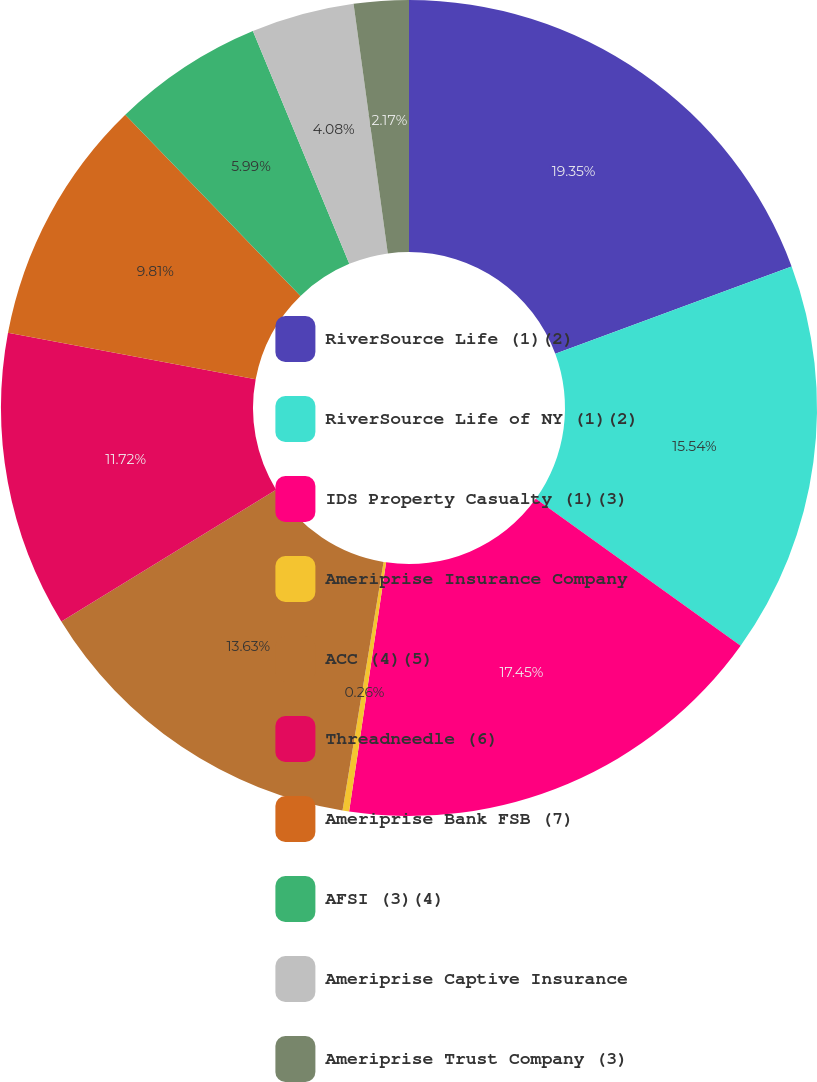Convert chart to OTSL. <chart><loc_0><loc_0><loc_500><loc_500><pie_chart><fcel>RiverSource Life (1)(2)<fcel>RiverSource Life of NY (1)(2)<fcel>IDS Property Casualty (1)(3)<fcel>Ameriprise Insurance Company<fcel>ACC (4)(5)<fcel>Threadneedle (6)<fcel>Ameriprise Bank FSB (7)<fcel>AFSI (3)(4)<fcel>Ameriprise Captive Insurance<fcel>Ameriprise Trust Company (3)<nl><fcel>19.36%<fcel>15.54%<fcel>17.45%<fcel>0.26%<fcel>13.63%<fcel>11.72%<fcel>9.81%<fcel>5.99%<fcel>4.08%<fcel>2.17%<nl></chart> 